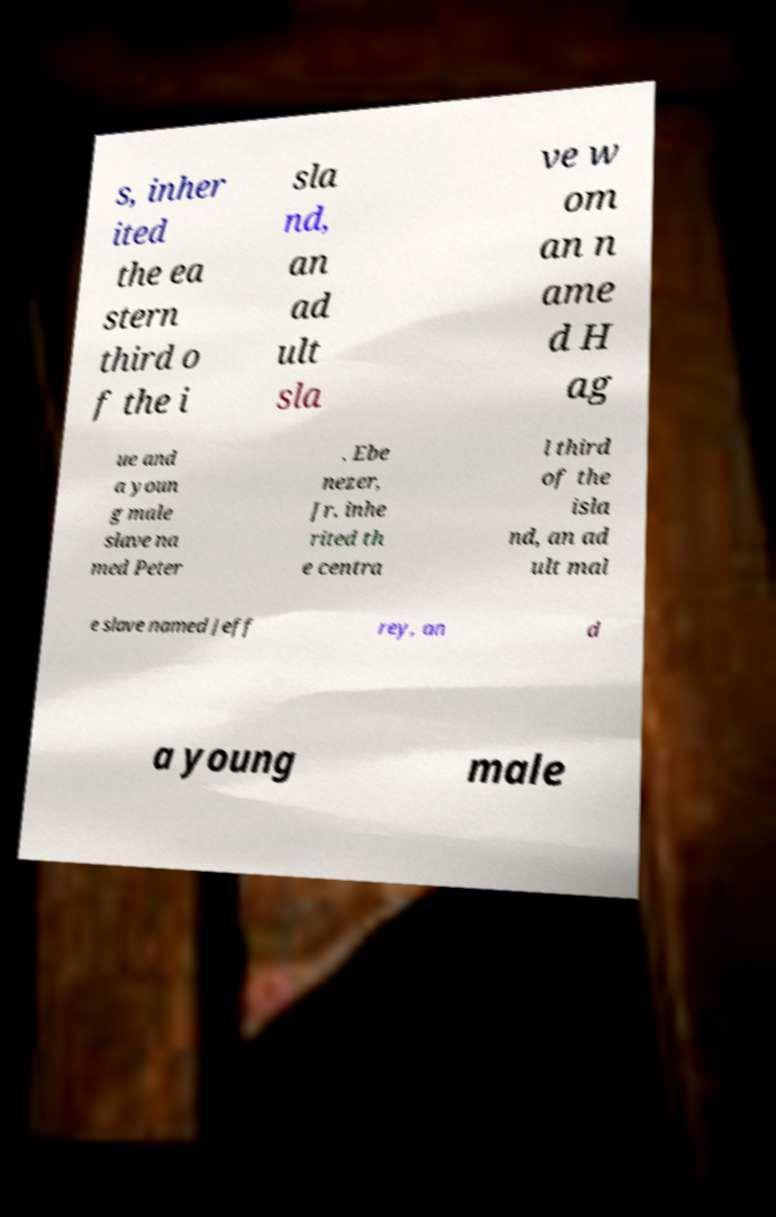Can you read and provide the text displayed in the image?This photo seems to have some interesting text. Can you extract and type it out for me? s, inher ited the ea stern third o f the i sla nd, an ad ult sla ve w om an n ame d H ag ue and a youn g male slave na med Peter . Ebe nezer, Jr. inhe rited th e centra l third of the isla nd, an ad ult mal e slave named Jeff rey, an d a young male 